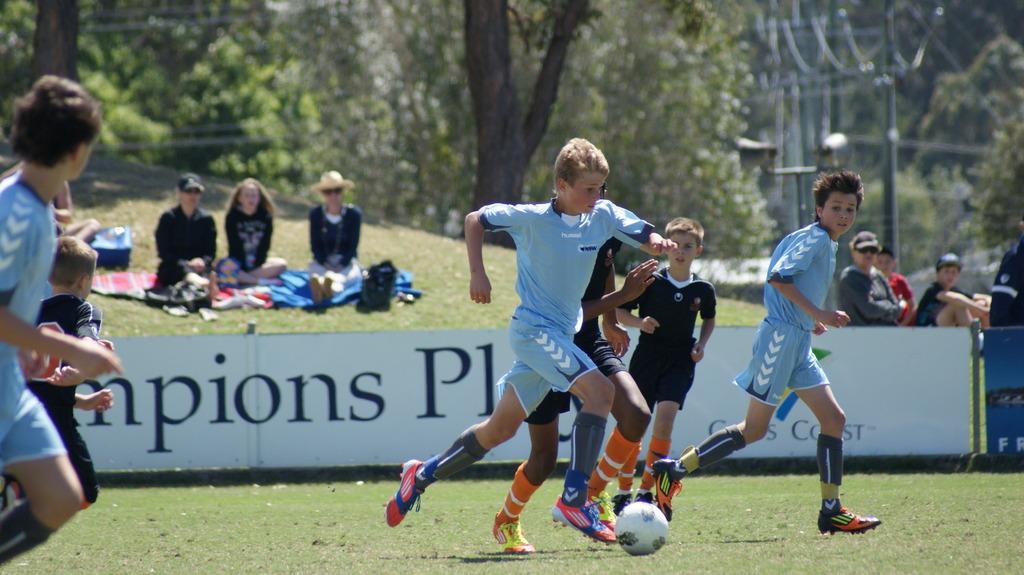Please provide a concise description of this image. This picture describes about group of people, these boys are playing game in the ground, we can see hoarding, seated people, poles and couple of trees. 